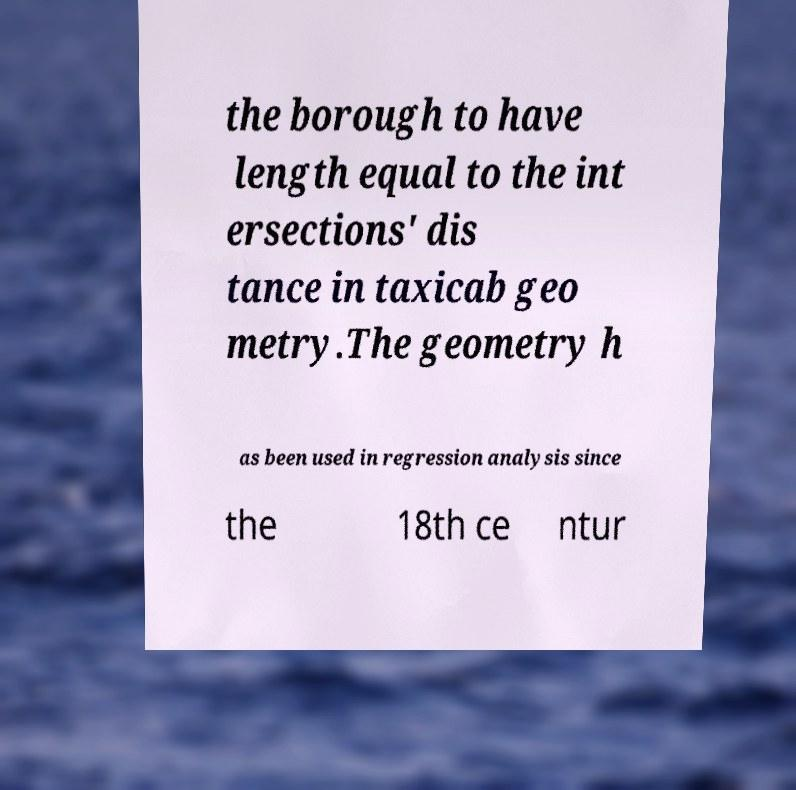There's text embedded in this image that I need extracted. Can you transcribe it verbatim? the borough to have length equal to the int ersections' dis tance in taxicab geo metry.The geometry h as been used in regression analysis since the 18th ce ntur 